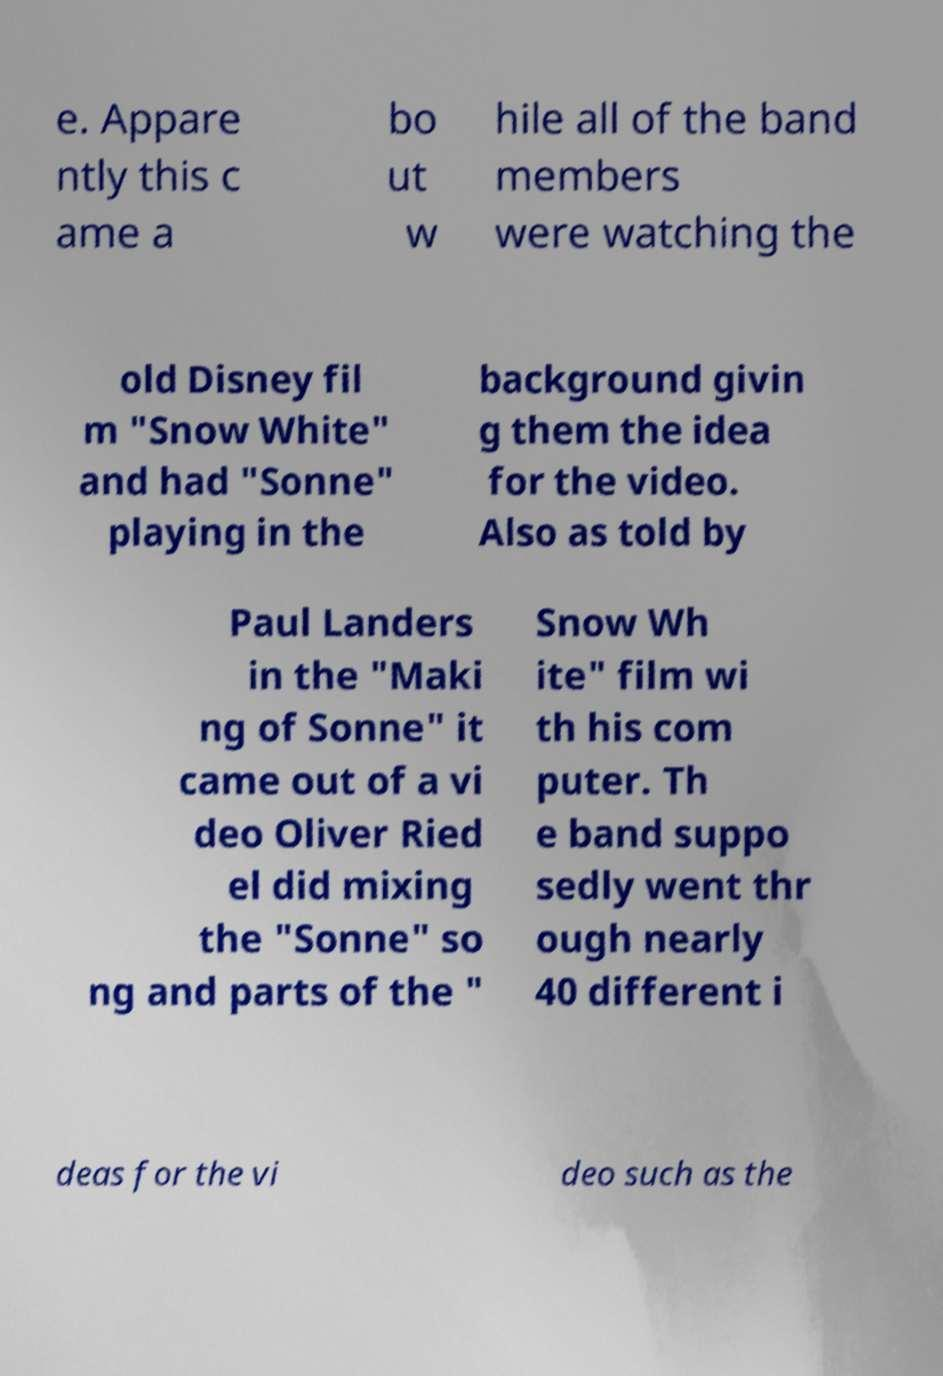Could you extract and type out the text from this image? e. Appare ntly this c ame a bo ut w hile all of the band members were watching the old Disney fil m "Snow White" and had "Sonne" playing in the background givin g them the idea for the video. Also as told by Paul Landers in the "Maki ng of Sonne" it came out of a vi deo Oliver Ried el did mixing the "Sonne" so ng and parts of the " Snow Wh ite" film wi th his com puter. Th e band suppo sedly went thr ough nearly 40 different i deas for the vi deo such as the 